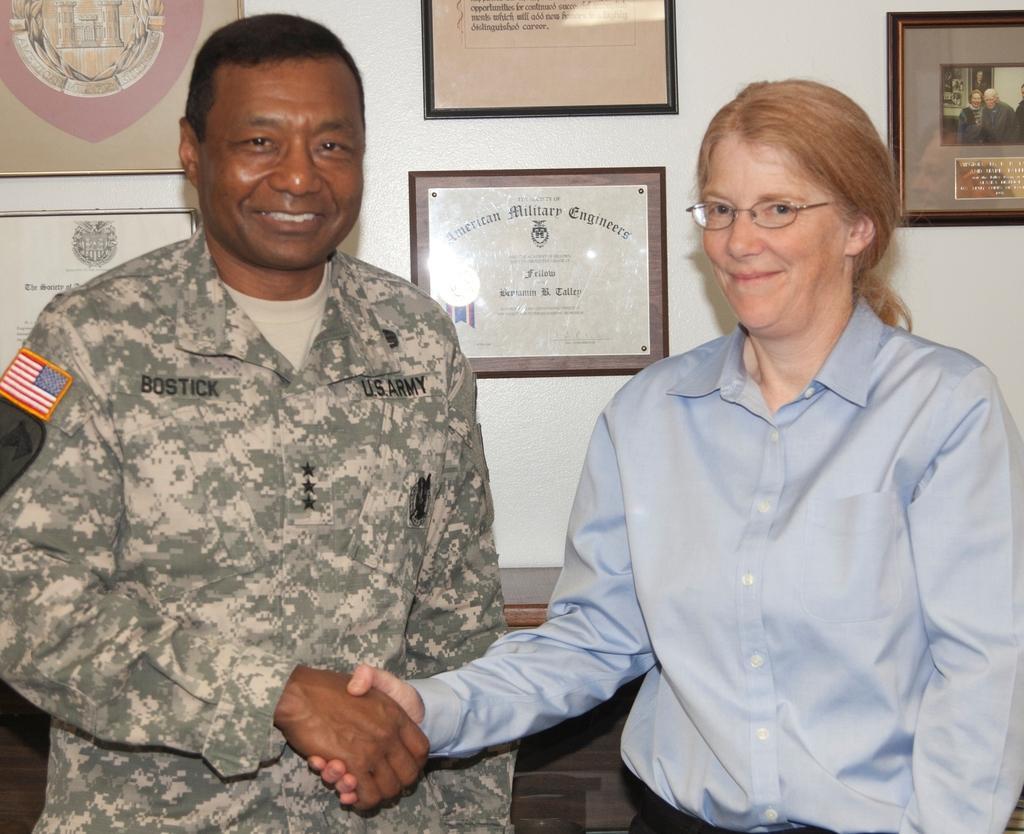How would you summarize this image in a sentence or two? In the center of the image we can see two persons are standing and they are smiling, which we can see on their faces. And we can see they are in different costumes. Among them, we can see one person is wearing glasses. In the background there is a wall, table, photo frames and a few other objects. 